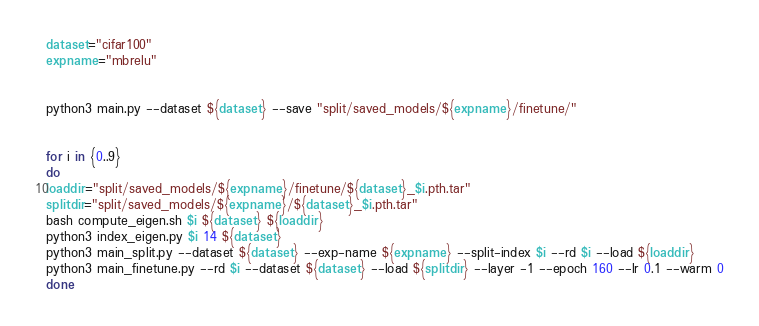Convert code to text. <code><loc_0><loc_0><loc_500><loc_500><_Bash_>dataset="cifar100"
expname="mbrelu"


python3 main.py --dataset ${dataset} --save "split/saved_models/${expname}/finetune/"


for i in {0..9}
do
loaddir="split/saved_models/${expname}/finetune/${dataset}_$i.pth.tar"
splitdir="split/saved_models/${expname}/${dataset}_$i.pth.tar"
bash compute_eigen.sh $i ${dataset} ${loaddir}
python3 index_eigen.py $i 14 ${dataset}
python3 main_split.py --dataset ${dataset} --exp-name ${expname} --split-index $i --rd $i --load ${loaddir}
python3 main_finetune.py --rd $i --dataset ${dataset} --load ${splitdir} --layer -1 --epoch 160 --lr 0.1 --warm 0
done
</code> 